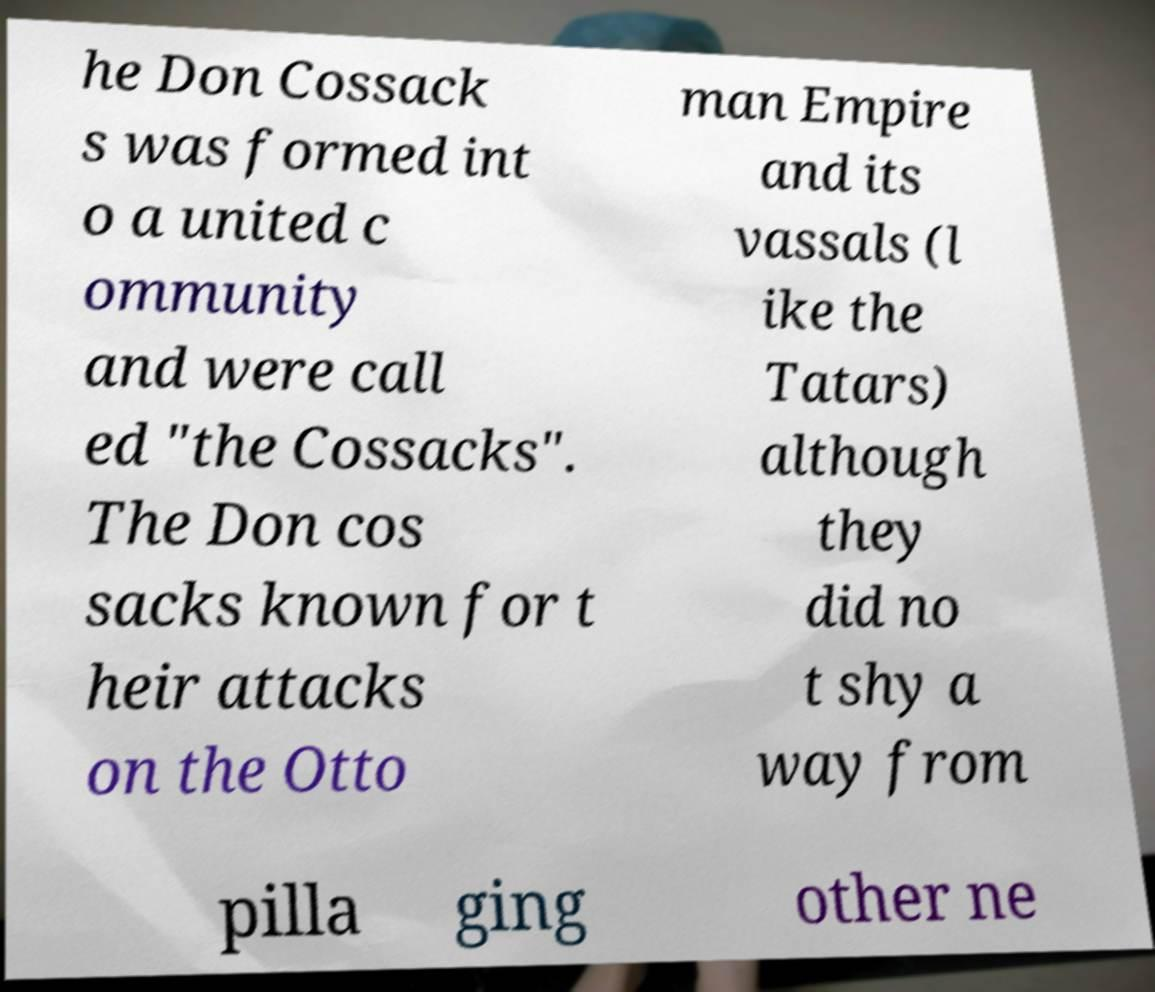For documentation purposes, I need the text within this image transcribed. Could you provide that? he Don Cossack s was formed int o a united c ommunity and were call ed "the Cossacks". The Don cos sacks known for t heir attacks on the Otto man Empire and its vassals (l ike the Tatars) although they did no t shy a way from pilla ging other ne 